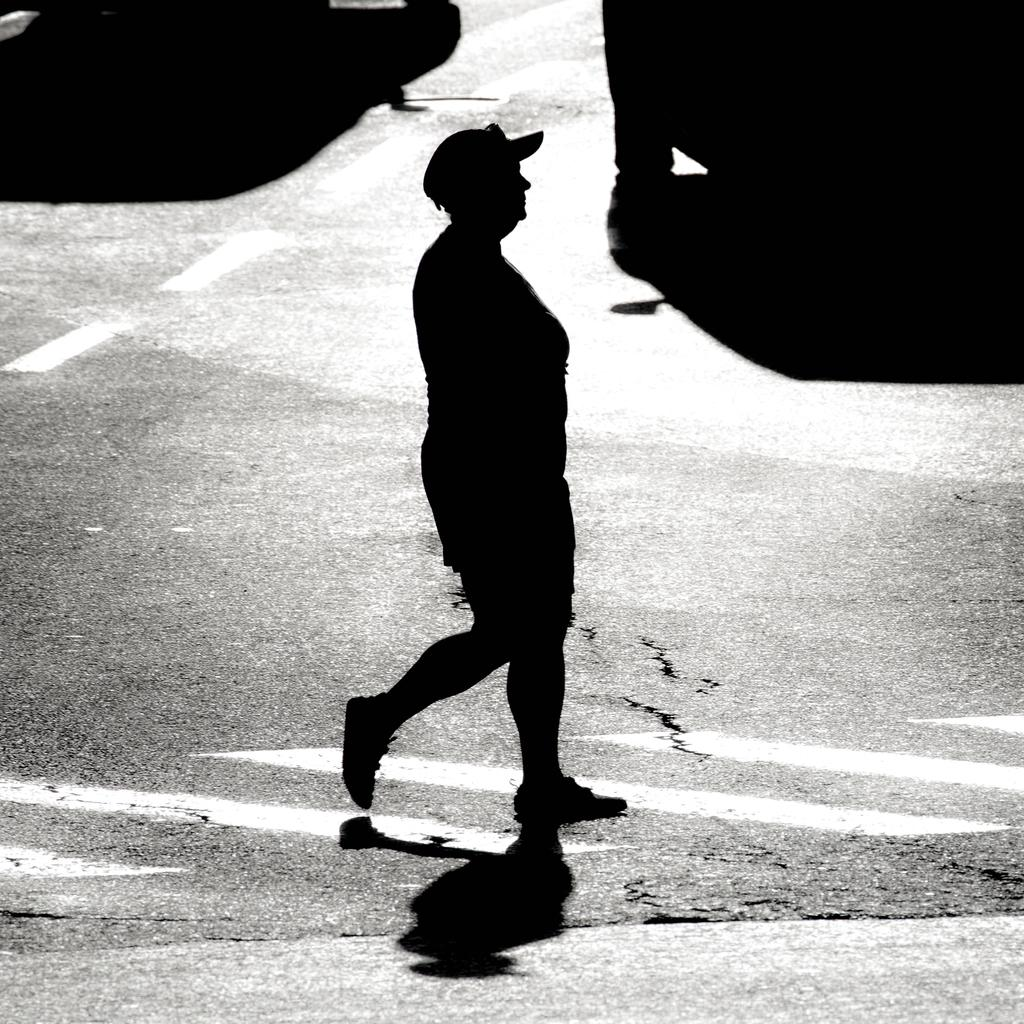What is the main subject of the image? There is a person walking in the image. What can be seen in the background of the image? There are vehicles visible in the background of the image. What is the color scheme of the image? The image is in black and white. What type of silver object can be seen in the image? There is no silver object present in the image. Is the person walking in the image being taken to jail? There is no indication in the image that the person walking is being taken to jail. 